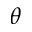Convert formula to latex. <formula><loc_0><loc_0><loc_500><loc_500>\theta</formula> 